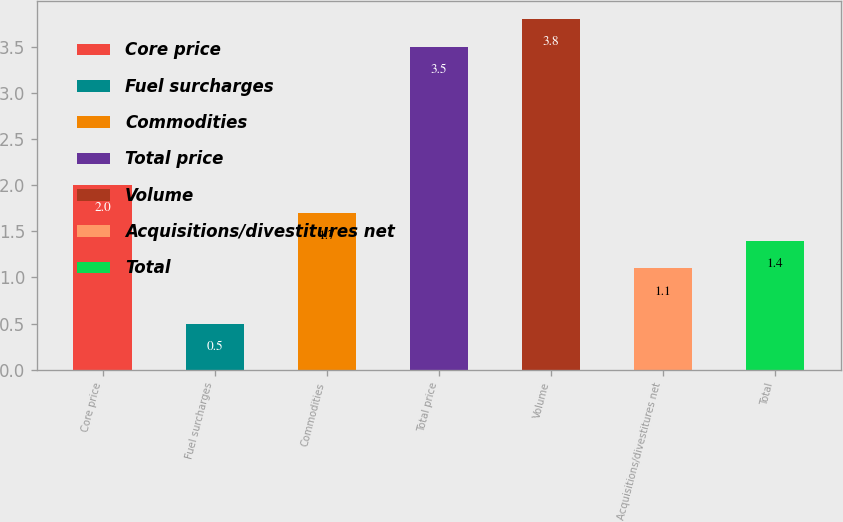<chart> <loc_0><loc_0><loc_500><loc_500><bar_chart><fcel>Core price<fcel>Fuel surcharges<fcel>Commodities<fcel>Total price<fcel>Volume<fcel>Acquisitions/divestitures net<fcel>Total<nl><fcel>2<fcel>0.5<fcel>1.7<fcel>3.5<fcel>3.8<fcel>1.1<fcel>1.4<nl></chart> 